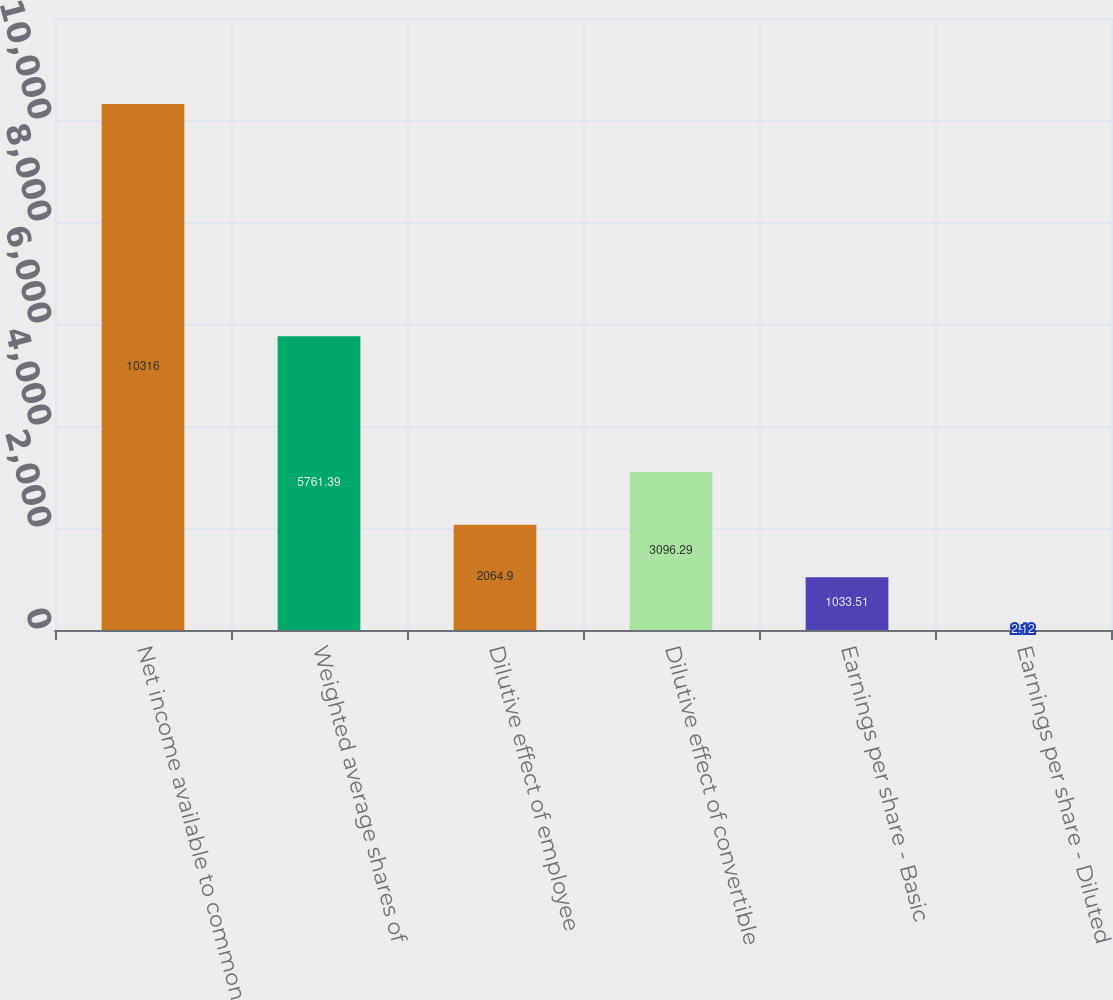<chart> <loc_0><loc_0><loc_500><loc_500><bar_chart><fcel>Net income available to common<fcel>Weighted average shares of<fcel>Dilutive effect of employee<fcel>Dilutive effect of convertible<fcel>Earnings per share - Basic<fcel>Earnings per share - Diluted<nl><fcel>10316<fcel>5761.39<fcel>2064.9<fcel>3096.29<fcel>1033.51<fcel>2.12<nl></chart> 